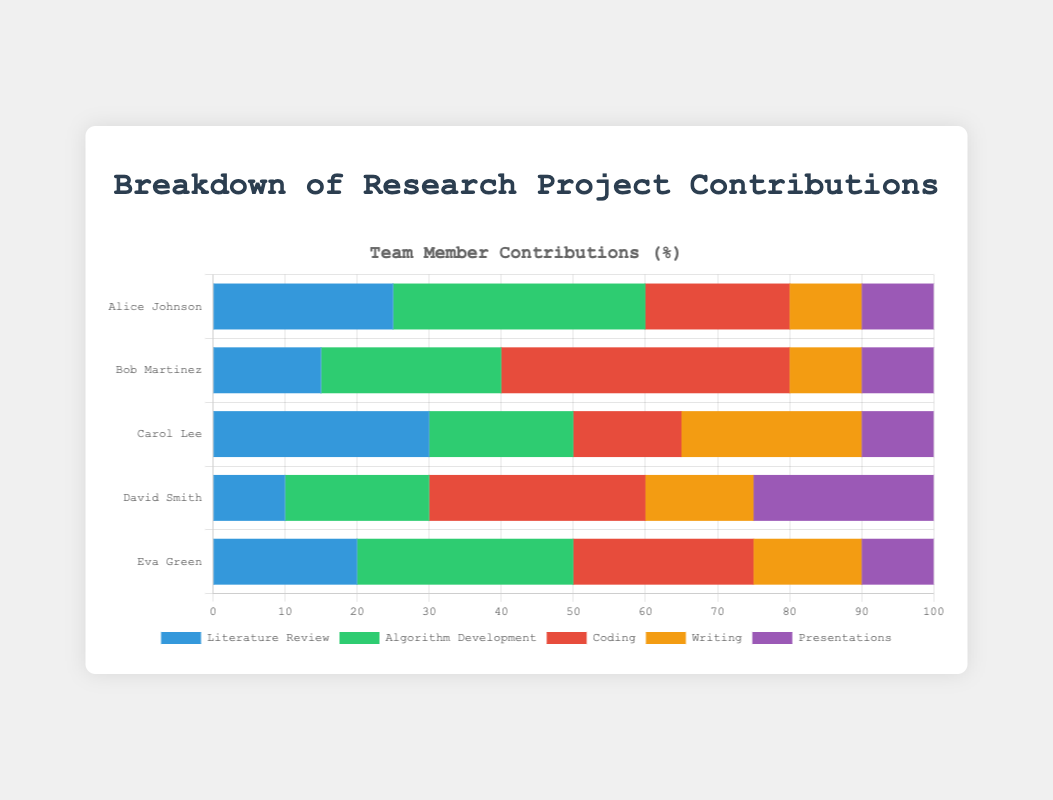Which team member contributed the most to Algorithm Development? From the horizontal stacked bar chart, look for the length of the green bar representing 'Algorithm Development' for each member. The longest green bar belongs to Eva Green.
Answer: Eva Green Who did the highest percentage of Coding? Examine all the bars representing 'Coding' (red) for each member. Bob Martinez has the longest red bar, indicating he did the most coding.
Answer: Bob Martinez Compare Alice Johnson and Carol Lee: who contributed more to Literature Review, and by how much? Find the blue bars representing 'Literature Review' for both Alice Johnson and Carol Lee. Alice's bar is 25, and Carol's is 30. Carol contributed 5% more.
Answer: Carol Lee, 5% What is the total percentage contribution of Bob Martinez to non-coding activities (sum of Literature Review, Algorithm Development, Writing, Presentations)? Add the percent contributions of Bob Martinez to activities other than Coding: 15 (Literature Review) + 25 (Algorithm Development) + 10 (Writing) + 10 (Presentations) = 60%
Answer: 60% By how much does David Smith's Presentation contribution exceed Alice Johnson's Presentation contribution? Check the bar representing 'Presentations' (purple) for both David Smith and Alice Johnson. David's percentage is 25, and Alice's is 10. The difference is 25 - 10 = 15%.
Answer: 15% Which two members have equal contributions to Writing? Look at the lengths of the yellow bars labeled 'Writing'. Both Bob Martinez and Eva Green have yellow bars of 10%.
Answer: Bob Martinez, Eva Green Between Eva Green and Carol Lee, who has a higher total percentage in Coding and Literature Review combined? Add the percentages for 'Coding' and 'Literature Review' for both members. Eva Green: 20 (Literature Review) + 25 (Coding) = 45%, Carol Lee: 30 (Literature Review) + 15 (Coding) = 45%. Both have 45%.
Answer: Equal Evaluate the median contribution percentage in Presentations for all team members. Arrange the percentages of 'Presentations' in ascending order: 10, 10, 10, 25, 25. The median value is the middle one: 10%.
Answer: 10% Which contribution category has the most equal distribution among all members? Assess the variance in bar lengths for each category. 'Presentations' bars are the most evenly sized across members.
Answer: Presentations 